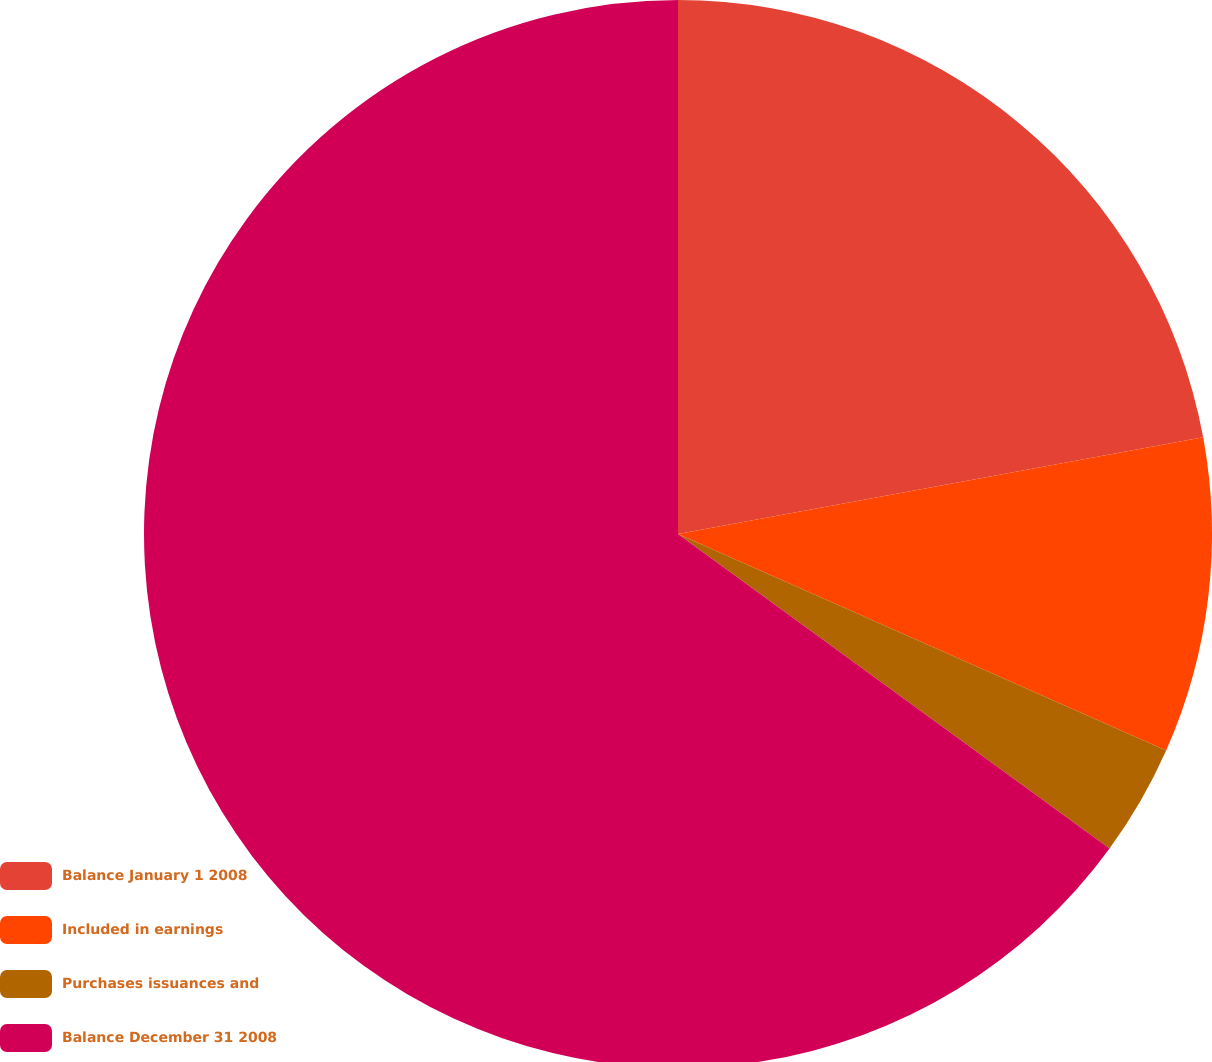Convert chart. <chart><loc_0><loc_0><loc_500><loc_500><pie_chart><fcel>Balance January 1 2008<fcel>Included in earnings<fcel>Purchases issuances and<fcel>Balance December 31 2008<nl><fcel>22.1%<fcel>9.54%<fcel>3.38%<fcel>64.97%<nl></chart> 